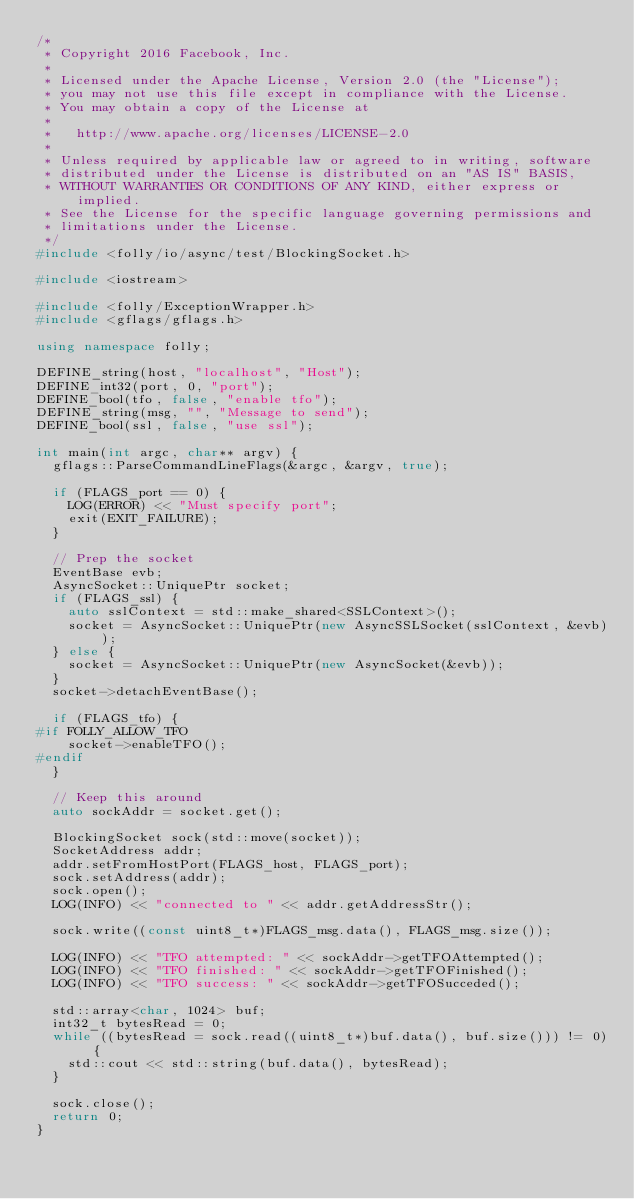<code> <loc_0><loc_0><loc_500><loc_500><_C++_>/*
 * Copyright 2016 Facebook, Inc.
 *
 * Licensed under the Apache License, Version 2.0 (the "License");
 * you may not use this file except in compliance with the License.
 * You may obtain a copy of the License at
 *
 *   http://www.apache.org/licenses/LICENSE-2.0
 *
 * Unless required by applicable law or agreed to in writing, software
 * distributed under the License is distributed on an "AS IS" BASIS,
 * WITHOUT WARRANTIES OR CONDITIONS OF ANY KIND, either express or implied.
 * See the License for the specific language governing permissions and
 * limitations under the License.
 */
#include <folly/io/async/test/BlockingSocket.h>

#include <iostream>

#include <folly/ExceptionWrapper.h>
#include <gflags/gflags.h>

using namespace folly;

DEFINE_string(host, "localhost", "Host");
DEFINE_int32(port, 0, "port");
DEFINE_bool(tfo, false, "enable tfo");
DEFINE_string(msg, "", "Message to send");
DEFINE_bool(ssl, false, "use ssl");

int main(int argc, char** argv) {
  gflags::ParseCommandLineFlags(&argc, &argv, true);

  if (FLAGS_port == 0) {
    LOG(ERROR) << "Must specify port";
    exit(EXIT_FAILURE);
  }

  // Prep the socket
  EventBase evb;
  AsyncSocket::UniquePtr socket;
  if (FLAGS_ssl) {
    auto sslContext = std::make_shared<SSLContext>();
    socket = AsyncSocket::UniquePtr(new AsyncSSLSocket(sslContext, &evb));
  } else {
    socket = AsyncSocket::UniquePtr(new AsyncSocket(&evb));
  }
  socket->detachEventBase();

  if (FLAGS_tfo) {
#if FOLLY_ALLOW_TFO
    socket->enableTFO();
#endif
  }

  // Keep this around
  auto sockAddr = socket.get();

  BlockingSocket sock(std::move(socket));
  SocketAddress addr;
  addr.setFromHostPort(FLAGS_host, FLAGS_port);
  sock.setAddress(addr);
  sock.open();
  LOG(INFO) << "connected to " << addr.getAddressStr();

  sock.write((const uint8_t*)FLAGS_msg.data(), FLAGS_msg.size());

  LOG(INFO) << "TFO attempted: " << sockAddr->getTFOAttempted();
  LOG(INFO) << "TFO finished: " << sockAddr->getTFOFinished();
  LOG(INFO) << "TFO success: " << sockAddr->getTFOSucceded();

  std::array<char, 1024> buf;
  int32_t bytesRead = 0;
  while ((bytesRead = sock.read((uint8_t*)buf.data(), buf.size())) != 0) {
    std::cout << std::string(buf.data(), bytesRead);
  }

  sock.close();
  return 0;
}
</code> 